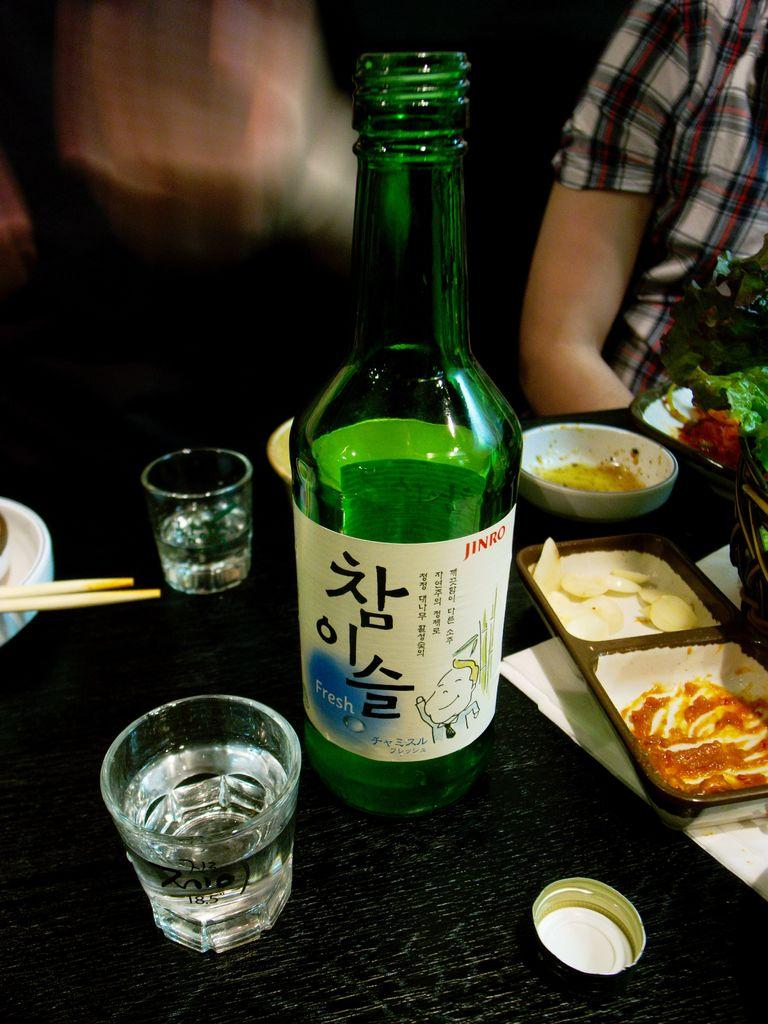<image>
Summarize the visual content of the image. A green bottle of Jinro brand alcoholic beverage shared between two glasses at a restaurant table. 